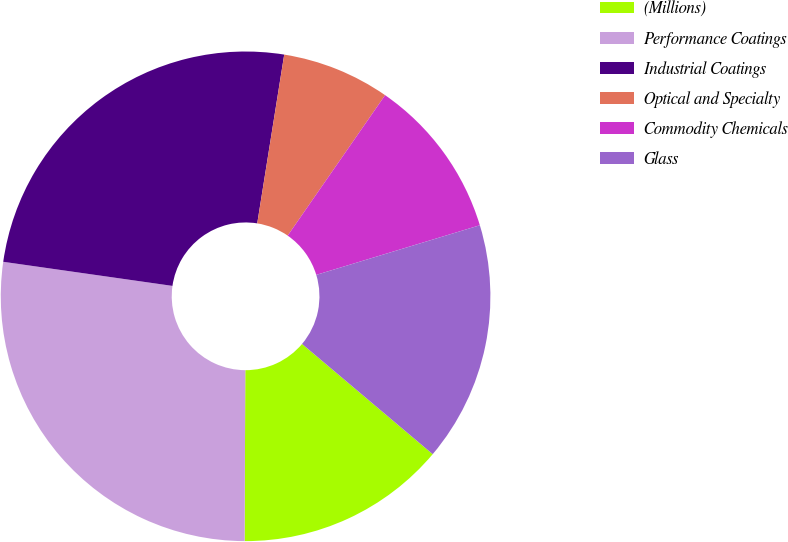<chart> <loc_0><loc_0><loc_500><loc_500><pie_chart><fcel>(Millions)<fcel>Performance Coatings<fcel>Industrial Coatings<fcel>Optical and Specialty<fcel>Commodity Chemicals<fcel>Glass<nl><fcel>13.91%<fcel>27.19%<fcel>25.27%<fcel>7.13%<fcel>10.66%<fcel>15.84%<nl></chart> 